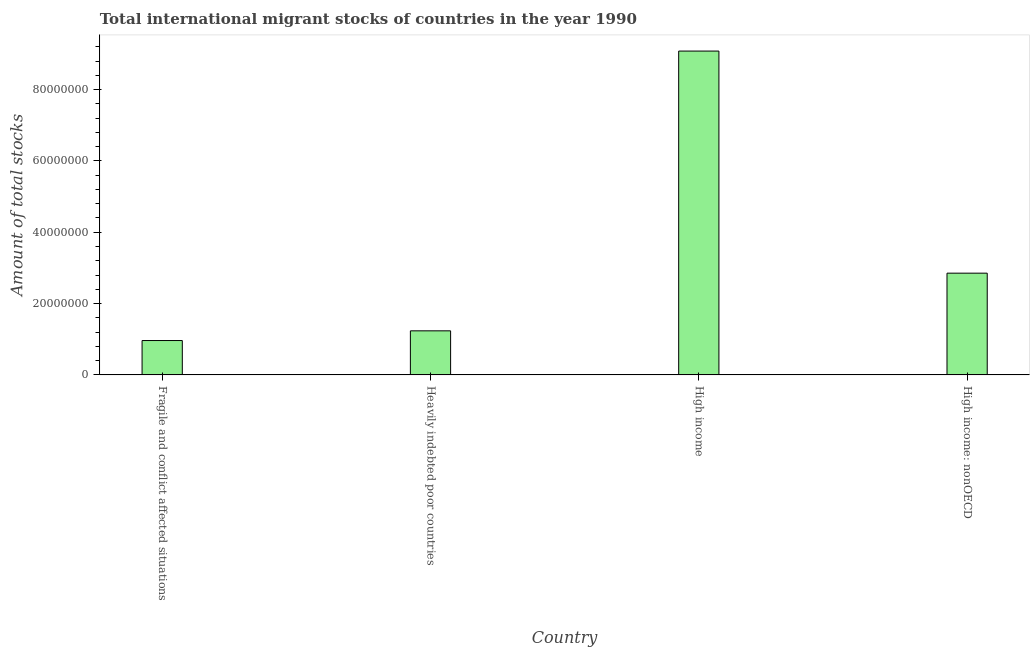Does the graph contain any zero values?
Make the answer very short. No. What is the title of the graph?
Give a very brief answer. Total international migrant stocks of countries in the year 1990. What is the label or title of the Y-axis?
Keep it short and to the point. Amount of total stocks. What is the total number of international migrant stock in Heavily indebted poor countries?
Your answer should be compact. 1.24e+07. Across all countries, what is the maximum total number of international migrant stock?
Provide a short and direct response. 9.08e+07. Across all countries, what is the minimum total number of international migrant stock?
Your response must be concise. 9.64e+06. In which country was the total number of international migrant stock maximum?
Ensure brevity in your answer.  High income. In which country was the total number of international migrant stock minimum?
Provide a short and direct response. Fragile and conflict affected situations. What is the sum of the total number of international migrant stock?
Keep it short and to the point. 1.41e+08. What is the difference between the total number of international migrant stock in Heavily indebted poor countries and High income: nonOECD?
Your answer should be compact. -1.62e+07. What is the average total number of international migrant stock per country?
Offer a very short reply. 3.53e+07. What is the median total number of international migrant stock?
Offer a very short reply. 2.04e+07. In how many countries, is the total number of international migrant stock greater than 28000000 ?
Your answer should be compact. 2. What is the ratio of the total number of international migrant stock in Heavily indebted poor countries to that in High income?
Provide a succinct answer. 0.14. Is the difference between the total number of international migrant stock in High income and High income: nonOECD greater than the difference between any two countries?
Your answer should be compact. No. What is the difference between the highest and the second highest total number of international migrant stock?
Provide a short and direct response. 6.23e+07. What is the difference between the highest and the lowest total number of international migrant stock?
Your answer should be compact. 8.12e+07. In how many countries, is the total number of international migrant stock greater than the average total number of international migrant stock taken over all countries?
Your answer should be compact. 1. How many bars are there?
Give a very brief answer. 4. How many countries are there in the graph?
Keep it short and to the point. 4. What is the difference between two consecutive major ticks on the Y-axis?
Provide a succinct answer. 2.00e+07. What is the Amount of total stocks of Fragile and conflict affected situations?
Your answer should be compact. 9.64e+06. What is the Amount of total stocks of Heavily indebted poor countries?
Offer a very short reply. 1.24e+07. What is the Amount of total stocks in High income?
Keep it short and to the point. 9.08e+07. What is the Amount of total stocks in High income: nonOECD?
Offer a very short reply. 2.85e+07. What is the difference between the Amount of total stocks in Fragile and conflict affected situations and Heavily indebted poor countries?
Your answer should be compact. -2.72e+06. What is the difference between the Amount of total stocks in Fragile and conflict affected situations and High income?
Give a very brief answer. -8.12e+07. What is the difference between the Amount of total stocks in Fragile and conflict affected situations and High income: nonOECD?
Your response must be concise. -1.89e+07. What is the difference between the Amount of total stocks in Heavily indebted poor countries and High income?
Your answer should be compact. -7.84e+07. What is the difference between the Amount of total stocks in Heavily indebted poor countries and High income: nonOECD?
Make the answer very short. -1.62e+07. What is the difference between the Amount of total stocks in High income and High income: nonOECD?
Ensure brevity in your answer.  6.23e+07. What is the ratio of the Amount of total stocks in Fragile and conflict affected situations to that in Heavily indebted poor countries?
Your answer should be compact. 0.78. What is the ratio of the Amount of total stocks in Fragile and conflict affected situations to that in High income?
Your response must be concise. 0.11. What is the ratio of the Amount of total stocks in Fragile and conflict affected situations to that in High income: nonOECD?
Give a very brief answer. 0.34. What is the ratio of the Amount of total stocks in Heavily indebted poor countries to that in High income?
Keep it short and to the point. 0.14. What is the ratio of the Amount of total stocks in Heavily indebted poor countries to that in High income: nonOECD?
Offer a terse response. 0.43. What is the ratio of the Amount of total stocks in High income to that in High income: nonOECD?
Offer a very short reply. 3.18. 